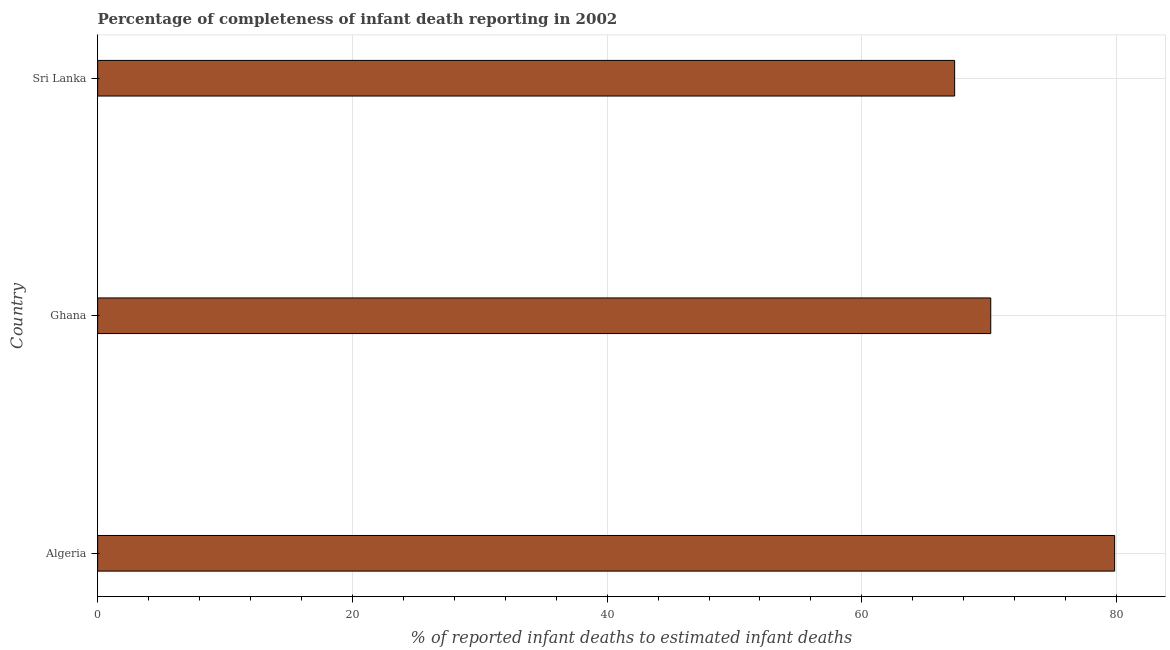Does the graph contain any zero values?
Offer a terse response. No. What is the title of the graph?
Provide a succinct answer. Percentage of completeness of infant death reporting in 2002. What is the label or title of the X-axis?
Make the answer very short. % of reported infant deaths to estimated infant deaths. What is the completeness of infant death reporting in Ghana?
Make the answer very short. 70.12. Across all countries, what is the maximum completeness of infant death reporting?
Make the answer very short. 79.84. Across all countries, what is the minimum completeness of infant death reporting?
Your answer should be compact. 67.28. In which country was the completeness of infant death reporting maximum?
Your answer should be very brief. Algeria. In which country was the completeness of infant death reporting minimum?
Your answer should be compact. Sri Lanka. What is the sum of the completeness of infant death reporting?
Your answer should be compact. 217.24. What is the difference between the completeness of infant death reporting in Ghana and Sri Lanka?
Make the answer very short. 2.83. What is the average completeness of infant death reporting per country?
Keep it short and to the point. 72.42. What is the median completeness of infant death reporting?
Your answer should be compact. 70.12. What is the ratio of the completeness of infant death reporting in Ghana to that in Sri Lanka?
Your answer should be very brief. 1.04. What is the difference between the highest and the second highest completeness of infant death reporting?
Offer a terse response. 9.73. What is the difference between the highest and the lowest completeness of infant death reporting?
Make the answer very short. 12.56. In how many countries, is the completeness of infant death reporting greater than the average completeness of infant death reporting taken over all countries?
Your answer should be compact. 1. How many bars are there?
Offer a very short reply. 3. How many countries are there in the graph?
Provide a succinct answer. 3. What is the difference between two consecutive major ticks on the X-axis?
Provide a short and direct response. 20. Are the values on the major ticks of X-axis written in scientific E-notation?
Provide a short and direct response. No. What is the % of reported infant deaths to estimated infant deaths of Algeria?
Keep it short and to the point. 79.84. What is the % of reported infant deaths to estimated infant deaths of Ghana?
Your answer should be compact. 70.12. What is the % of reported infant deaths to estimated infant deaths of Sri Lanka?
Offer a very short reply. 67.28. What is the difference between the % of reported infant deaths to estimated infant deaths in Algeria and Ghana?
Keep it short and to the point. 9.73. What is the difference between the % of reported infant deaths to estimated infant deaths in Algeria and Sri Lanka?
Provide a short and direct response. 12.56. What is the difference between the % of reported infant deaths to estimated infant deaths in Ghana and Sri Lanka?
Give a very brief answer. 2.83. What is the ratio of the % of reported infant deaths to estimated infant deaths in Algeria to that in Ghana?
Your answer should be very brief. 1.14. What is the ratio of the % of reported infant deaths to estimated infant deaths in Algeria to that in Sri Lanka?
Give a very brief answer. 1.19. What is the ratio of the % of reported infant deaths to estimated infant deaths in Ghana to that in Sri Lanka?
Offer a very short reply. 1.04. 